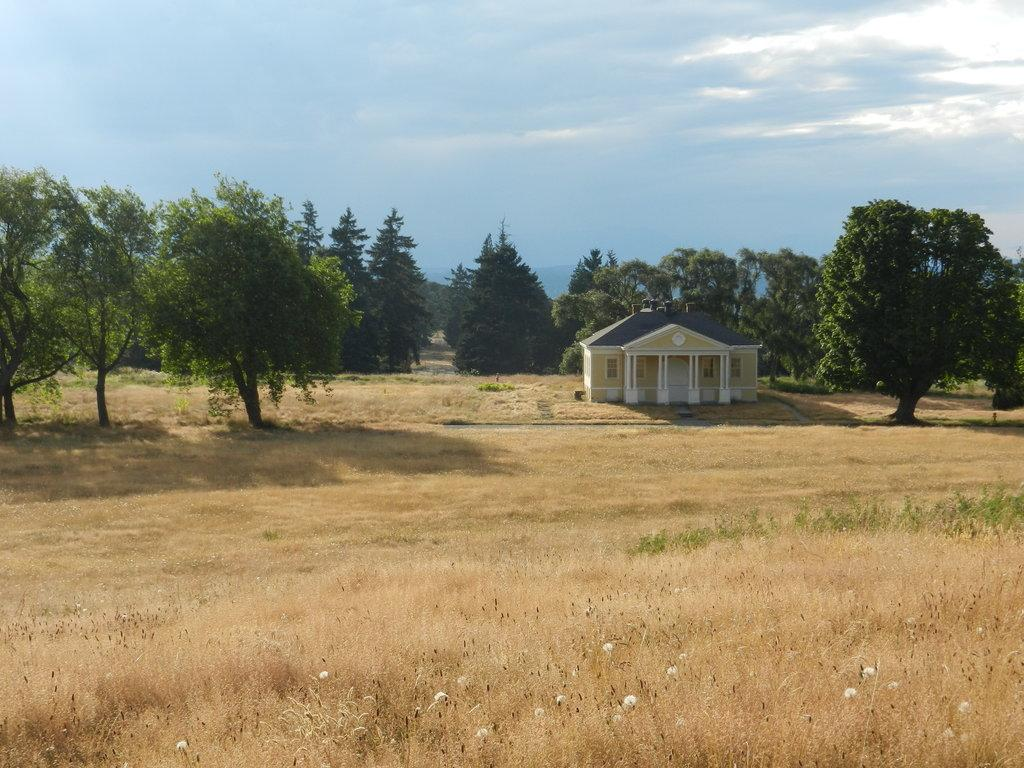What type of vegetation can be seen in the image? There is grass and trees in the image. What type of structure is visible in the image? There is a house in the image. What can be observed about the lighting in the image? Shadows are visible in the image. What is visible in the sky in the image? Clouds and the sky are present in the image. What type of flowers are growing near the house in the image? There are no flowers mentioned or visible in the image. 